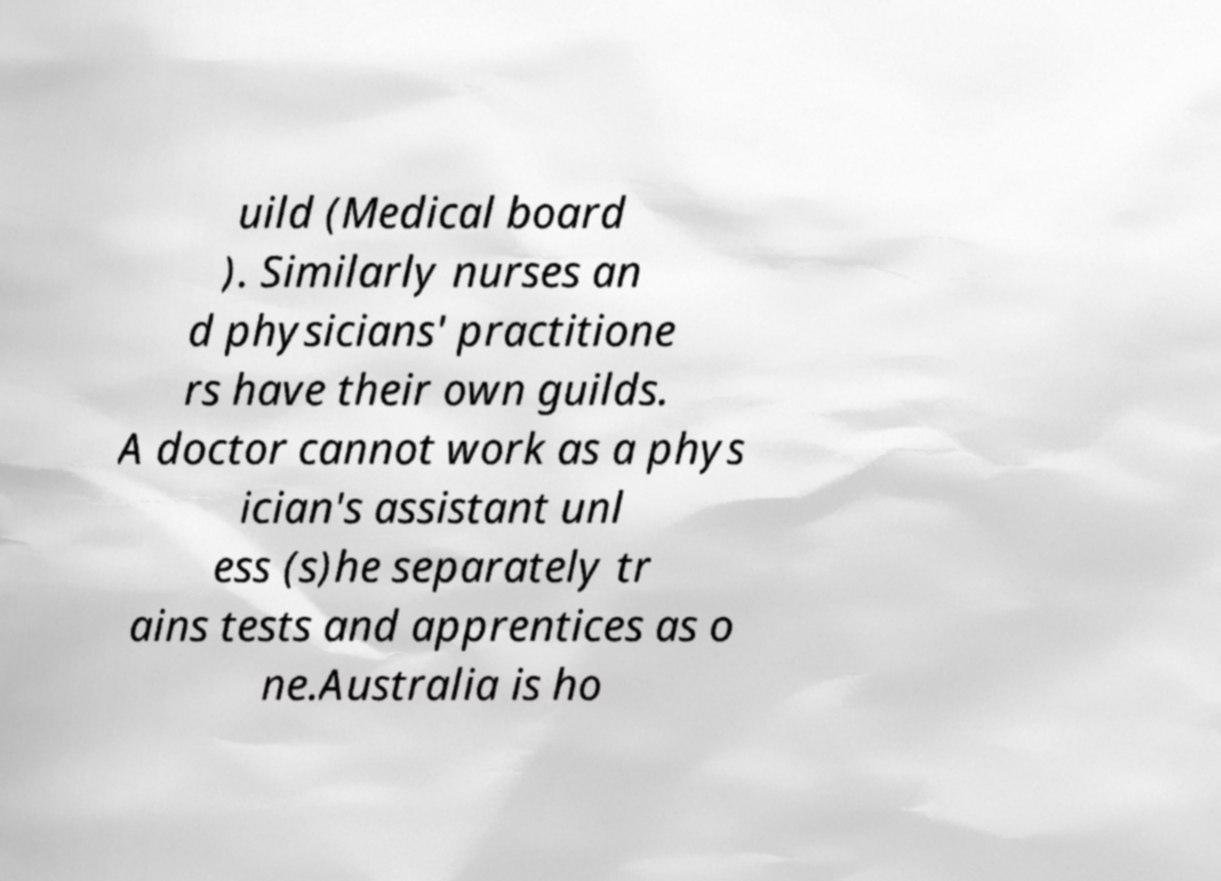I need the written content from this picture converted into text. Can you do that? uild (Medical board ). Similarly nurses an d physicians' practitione rs have their own guilds. A doctor cannot work as a phys ician's assistant unl ess (s)he separately tr ains tests and apprentices as o ne.Australia is ho 